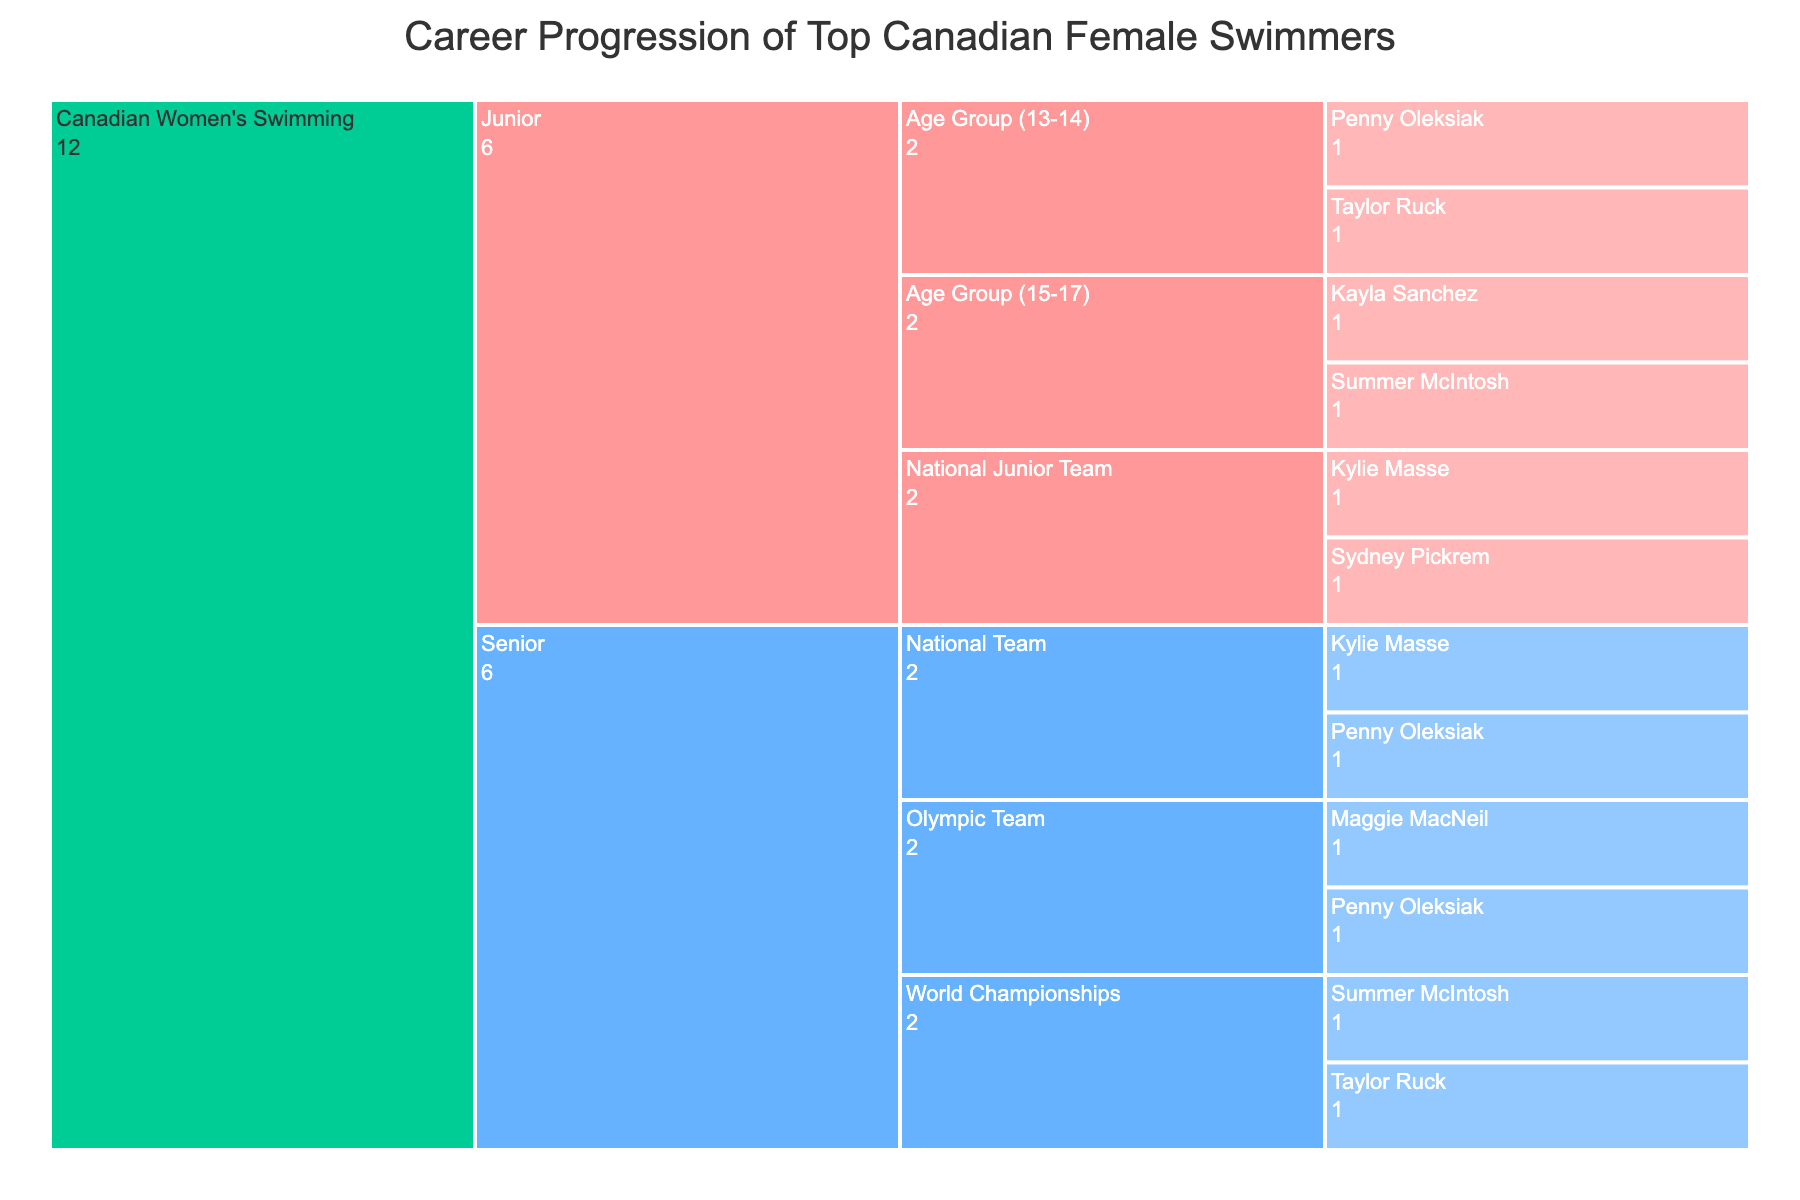What is the title of the figure? The title is located at the top of the Icicle chart. It specifies the main focus of the chart.
Answer: Career Progression of Top Canadian Female Swimmers What are the color-coded levels in the chart? There are two main levels color-coded in the chart. "Junior" is colored in pink, and "Senior" is colored in blue.
Answer: Junior, Senior Which swimmer is present in both "Junior" and "Senior" levels? By looking at the swimmer names under both "Junior" and "Senior" levels, we can find the common name. Penny Oleksiak is found in both.
Answer: Penny Oleksiak How many swimmers are in the "Senior" National Team? Under the "Senior" level, look for the "National Team" category and count the swimmers listed. There are 2 swimmers.
Answer: 2 Who are the swimmers in the "Junior" Age Group (15-17) category? Within the "Junior" level, locate the "Age Group (15-17)" category and identify the swimmers listed. Summer McIntosh and Kayla Sanchez are in this category.
Answer: Summer McIntosh, Kayla Sanchez Compare the number of swimmers who progressed to the "Olympic Team" versus the "World Championships." Under the "Senior" level, count the swimmers under both the "Olympic Team" and "World Championships" and compare. The "Olympic Team" has 2 swimmers and the "World Championships" also has 2 swimmers.
Answer: Equal Which categories exist under the "Junior" level? Within the "Junior" level, identify all the sub-categories listed. They include "Age Group (13-14)", "Age Group (15-17)", and "National Junior Team".
Answer: Age Group (13-14), Age Group (15-17), National Junior Team Count the total number of swimmers mentioned in the entire chart. Sum all swimmers listed across both "Junior" and "Senior" levels. There are 10 swimmers in total.
Answer: 10 How many swimmers are in the "Senior" level overall? Add all swimmers listed under the "Senior" level categories: 2 (National Team) + 2 (Olympic Team) + 2 (World Championships). The total is 6.
Answer: 6 